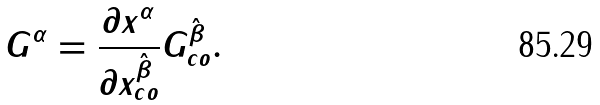Convert formula to latex. <formula><loc_0><loc_0><loc_500><loc_500>G ^ { \alpha } = \frac { \partial x ^ { \alpha } } { \partial x _ { c o } ^ { \hat { \beta } } } G _ { c o } ^ { \hat { \beta } } .</formula> 